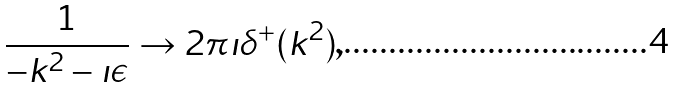Convert formula to latex. <formula><loc_0><loc_0><loc_500><loc_500>\frac { 1 } { - k ^ { 2 } - \imath \epsilon } \to 2 \pi \imath \delta ^ { + } ( k ^ { 2 } ) ,</formula> 